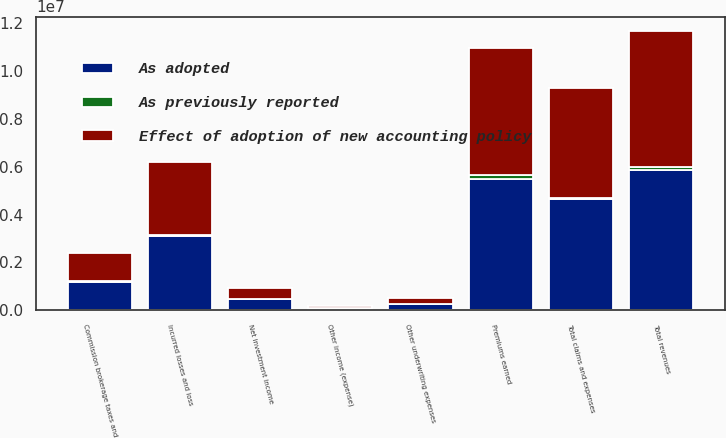Convert chart. <chart><loc_0><loc_0><loc_500><loc_500><stacked_bar_chart><ecel><fcel>Premiums earned<fcel>Net investment income<fcel>Other income (expense)<fcel>Total revenues<fcel>Incurred losses and loss<fcel>Commission brokerage taxes and<fcel>Other underwriting expenses<fcel>Total claims and expenses<nl><fcel>As adopted<fcel>5.48146e+06<fcel>473825<fcel>60435<fcel>5.83789e+06<fcel>3.10192e+06<fcel>1.20204e+06<fcel>265984<fcel>4.62938e+06<nl><fcel>As previously reported<fcel>188617<fcel>352<fcel>27845<fcel>161124<fcel>37200<fcel>18390<fcel>8915<fcel>64505<nl><fcel>Effect of adoption of new accounting policy<fcel>5.29284e+06<fcel>473473<fcel>88280<fcel>5.67676e+06<fcel>3.06472e+06<fcel>1.18365e+06<fcel>257069<fcel>4.56488e+06<nl></chart> 